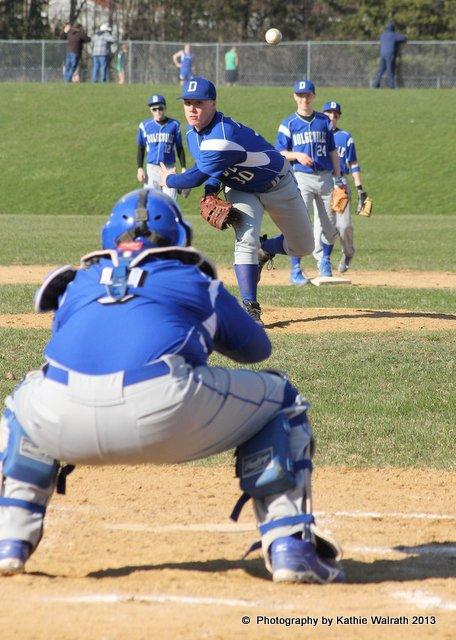What sport is this?
Be succinct. Baseball. Is the ball in motion?
Concise answer only. Yes. To what player is the ball traveling to?
Short answer required. Catcher. 